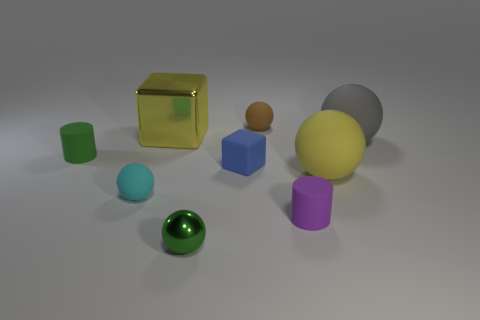Subtract all small brown matte balls. How many balls are left? 4 Subtract all balls. How many objects are left? 4 Subtract 4 spheres. How many spheres are left? 1 Add 5 cyan matte spheres. How many cyan matte spheres are left? 6 Add 5 small rubber spheres. How many small rubber spheres exist? 7 Subtract all brown balls. How many balls are left? 4 Subtract 0 blue spheres. How many objects are left? 9 Subtract all blue blocks. Subtract all cyan balls. How many blocks are left? 1 Subtract all blue cylinders. How many brown balls are left? 1 Subtract all rubber balls. Subtract all rubber cylinders. How many objects are left? 3 